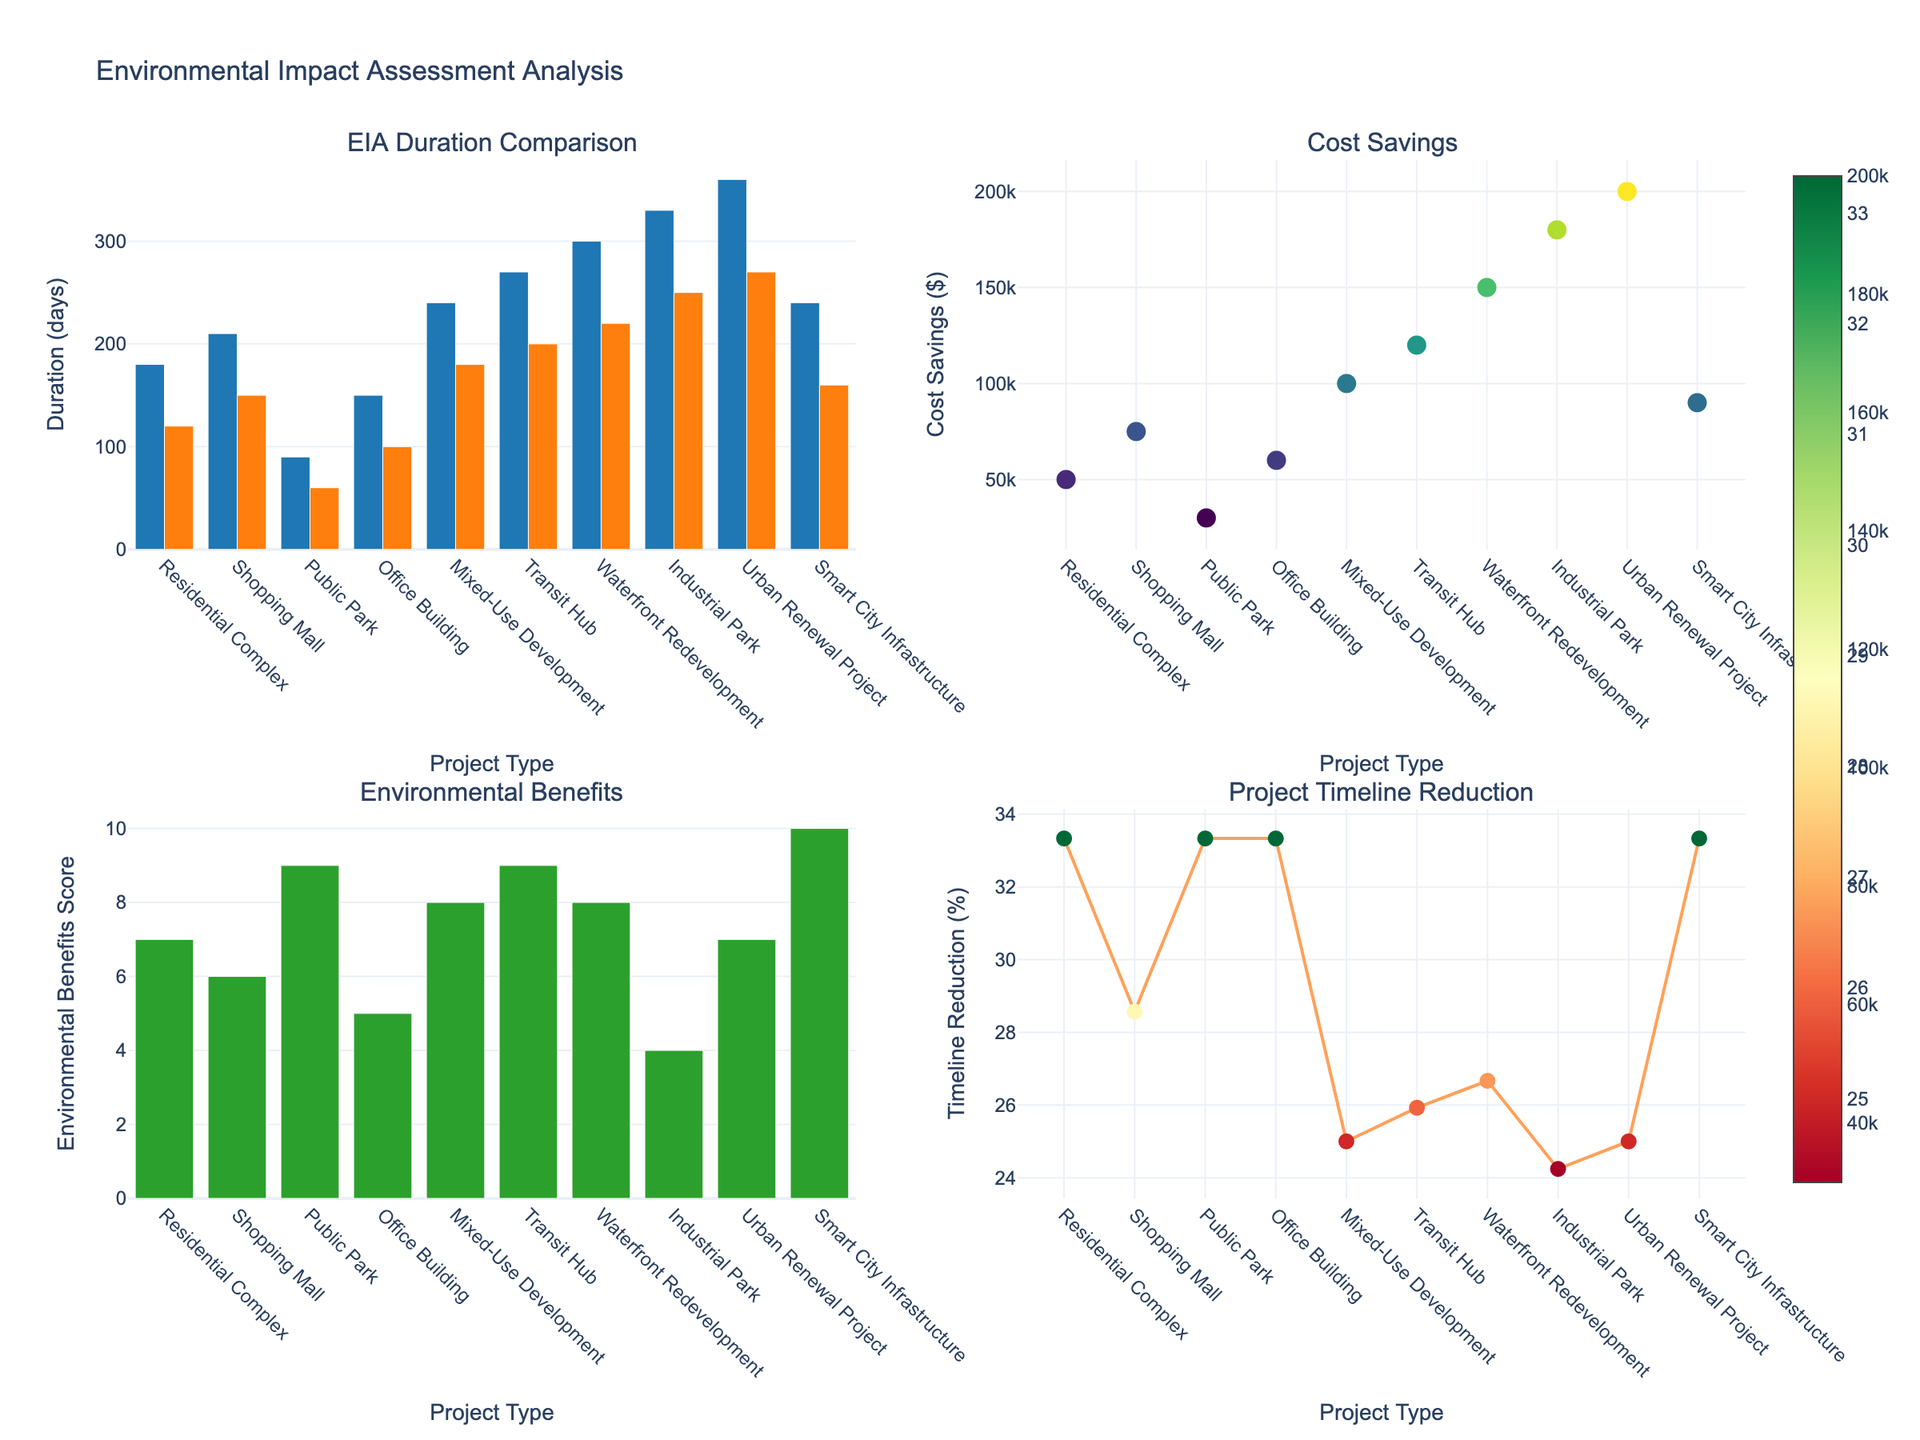What is the title of the figure? The title of the figure is usually displayed prominently at the top of the plot. By looking at the visual representation, the title can be seen as "Environmental Impact Assessment Analysis".
Answer: Environmental Impact Assessment Analysis How many project types are compared in this figure? Counting the different categories displayed on the x-axis of any of the subplots reveals how many different project types are being compared. In this case, counting the bar or scatter plot categories gives 10 different project types.
Answer: 10 Which project type shows the highest cost savings with advanced technologies? By observing the scatter plot in the top right subplot titled "Cost Savings", we can identify the project with the data point at the highest position on the y-axis. The highest cost savings is shown for the "Urban Renewal Project".
Answer: Urban Renewal Project What is the environmental benefits score for a Transit Hub project? Referring to the bar chart in the bottom left subplot titled "Environmental Benefits", we find the bar labeled "Transit Hub" and check its height on the y-axis. The environmental benefits score for a Transit Hub project is 9.
Answer: 9 Which project type has the most significant reduction in EIA duration percentage-wise? Looking at the line plot in the bottom right subplot that depicts "Project Timeline Reduction (%)", we identify the project type on the x-axis with the highest y-value. By examining the plot, "Urban Renewal Project" shows the most significant reduction.
Answer: Urban Renewal Project What are the traditional and advanced EIA durations for a Waterfront Redevelopment project? In the bar plot titled "EIA Duration Comparison" in the top left subplot, locate the bars for "Waterfront Redevelopment". The heights of these bars represent the durations. Traditional EIA is 300 days, and advanced EIA is 220 days.
Answer: 300 days and 220 days What is the average environmental benefits score across all project types? Adding up all the environmental benefits scores from the "Environmental Benefits" bar chart (7 + 6 + 9 + 5 + 8 + 9 + 8 + 4 + 7 + 10) and dividing by the number of project types (10). The sum is 73, so the average is 73 / 10.
Answer: 7.3 Which project shows the least timeline reduction percentage-wise? From the scatter plot in the bottom right titled "Project Timeline Reduction (%)", we find the project type with the lowest y-value. In this case, the "Industrial Park" has the least reduction.
Answer: Industrial Park 